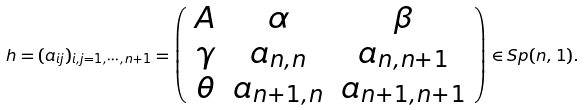<formula> <loc_0><loc_0><loc_500><loc_500>h = ( a _ { i j } ) _ { i , j = 1 , \cdots , n + 1 } = \left ( \begin{array} { c c c } A & \alpha & \beta \\ \gamma & a _ { n , n } & a _ { n , n + 1 } \\ \theta & a _ { n + 1 , n } & a _ { n + 1 , n + 1 } \\ \end{array} \right ) \in S p ( n , 1 ) .</formula> 